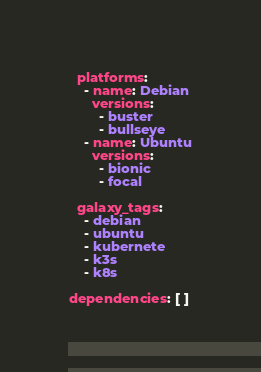Convert code to text. <code><loc_0><loc_0><loc_500><loc_500><_YAML_>
  platforms:
    - name: Debian
      versions:
        - buster
        - bullseye
    - name: Ubuntu
      versions:
        - bionic
        - focal

  galaxy_tags:
    - debian
    - ubuntu
    - kubernete
    - k3s
    - k8s

dependencies: [ ]
</code> 